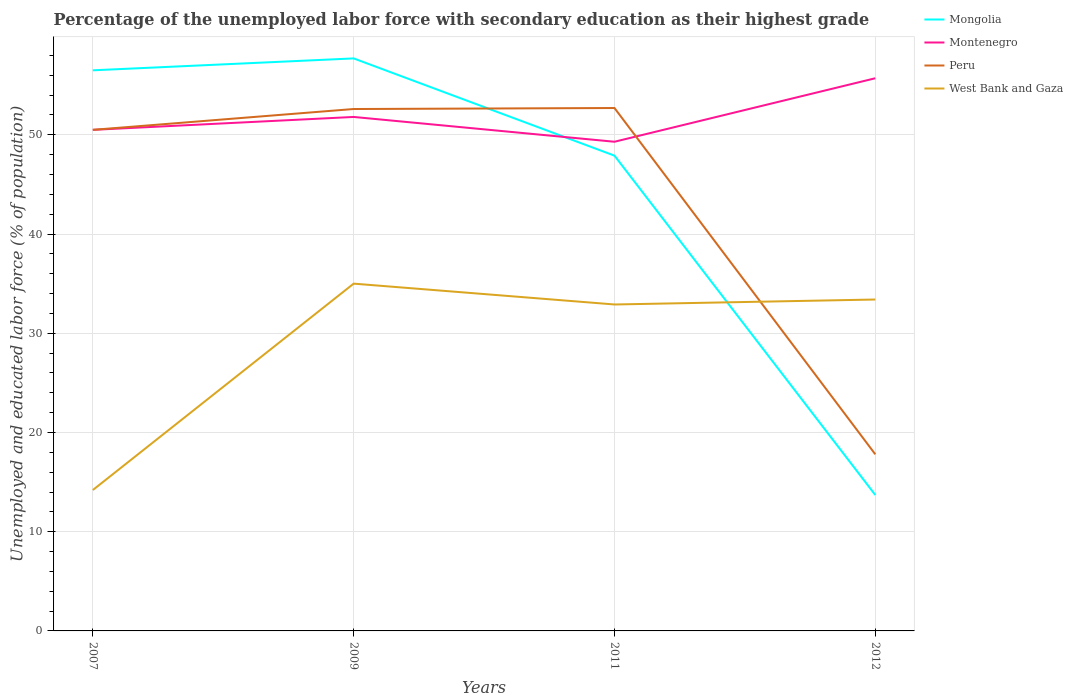Does the line corresponding to West Bank and Gaza intersect with the line corresponding to Montenegro?
Your answer should be very brief. No. Is the number of lines equal to the number of legend labels?
Offer a very short reply. Yes. Across all years, what is the maximum percentage of the unemployed labor force with secondary education in Peru?
Offer a very short reply. 17.8. What is the total percentage of the unemployed labor force with secondary education in West Bank and Gaza in the graph?
Offer a very short reply. -19.2. What is the difference between the highest and the second highest percentage of the unemployed labor force with secondary education in Montenegro?
Provide a succinct answer. 6.4. What is the difference between the highest and the lowest percentage of the unemployed labor force with secondary education in Peru?
Keep it short and to the point. 3. How many years are there in the graph?
Provide a short and direct response. 4. Are the values on the major ticks of Y-axis written in scientific E-notation?
Provide a succinct answer. No. Does the graph contain any zero values?
Your answer should be compact. No. Does the graph contain grids?
Your answer should be very brief. Yes. Where does the legend appear in the graph?
Your response must be concise. Top right. What is the title of the graph?
Ensure brevity in your answer.  Percentage of the unemployed labor force with secondary education as their highest grade. Does "Austria" appear as one of the legend labels in the graph?
Your answer should be compact. No. What is the label or title of the Y-axis?
Your answer should be compact. Unemployed and educated labor force (% of population). What is the Unemployed and educated labor force (% of population) of Mongolia in 2007?
Your answer should be very brief. 56.5. What is the Unemployed and educated labor force (% of population) of Montenegro in 2007?
Give a very brief answer. 50.5. What is the Unemployed and educated labor force (% of population) in Peru in 2007?
Your answer should be very brief. 50.5. What is the Unemployed and educated labor force (% of population) in West Bank and Gaza in 2007?
Give a very brief answer. 14.2. What is the Unemployed and educated labor force (% of population) of Mongolia in 2009?
Ensure brevity in your answer.  57.7. What is the Unemployed and educated labor force (% of population) in Montenegro in 2009?
Offer a very short reply. 51.8. What is the Unemployed and educated labor force (% of population) of Peru in 2009?
Give a very brief answer. 52.6. What is the Unemployed and educated labor force (% of population) of West Bank and Gaza in 2009?
Your answer should be compact. 35. What is the Unemployed and educated labor force (% of population) in Mongolia in 2011?
Provide a short and direct response. 47.9. What is the Unemployed and educated labor force (% of population) in Montenegro in 2011?
Provide a succinct answer. 49.3. What is the Unemployed and educated labor force (% of population) in Peru in 2011?
Give a very brief answer. 52.7. What is the Unemployed and educated labor force (% of population) in West Bank and Gaza in 2011?
Offer a terse response. 32.9. What is the Unemployed and educated labor force (% of population) of Mongolia in 2012?
Make the answer very short. 13.7. What is the Unemployed and educated labor force (% of population) of Montenegro in 2012?
Provide a succinct answer. 55.7. What is the Unemployed and educated labor force (% of population) in Peru in 2012?
Keep it short and to the point. 17.8. What is the Unemployed and educated labor force (% of population) in West Bank and Gaza in 2012?
Your answer should be very brief. 33.4. Across all years, what is the maximum Unemployed and educated labor force (% of population) in Mongolia?
Ensure brevity in your answer.  57.7. Across all years, what is the maximum Unemployed and educated labor force (% of population) in Montenegro?
Your answer should be very brief. 55.7. Across all years, what is the maximum Unemployed and educated labor force (% of population) in Peru?
Give a very brief answer. 52.7. Across all years, what is the minimum Unemployed and educated labor force (% of population) in Mongolia?
Keep it short and to the point. 13.7. Across all years, what is the minimum Unemployed and educated labor force (% of population) of Montenegro?
Provide a short and direct response. 49.3. Across all years, what is the minimum Unemployed and educated labor force (% of population) of Peru?
Your response must be concise. 17.8. Across all years, what is the minimum Unemployed and educated labor force (% of population) in West Bank and Gaza?
Offer a very short reply. 14.2. What is the total Unemployed and educated labor force (% of population) in Mongolia in the graph?
Give a very brief answer. 175.8. What is the total Unemployed and educated labor force (% of population) of Montenegro in the graph?
Offer a very short reply. 207.3. What is the total Unemployed and educated labor force (% of population) in Peru in the graph?
Offer a terse response. 173.6. What is the total Unemployed and educated labor force (% of population) in West Bank and Gaza in the graph?
Your response must be concise. 115.5. What is the difference between the Unemployed and educated labor force (% of population) of West Bank and Gaza in 2007 and that in 2009?
Keep it short and to the point. -20.8. What is the difference between the Unemployed and educated labor force (% of population) of Mongolia in 2007 and that in 2011?
Offer a very short reply. 8.6. What is the difference between the Unemployed and educated labor force (% of population) of Peru in 2007 and that in 2011?
Ensure brevity in your answer.  -2.2. What is the difference between the Unemployed and educated labor force (% of population) in West Bank and Gaza in 2007 and that in 2011?
Your answer should be compact. -18.7. What is the difference between the Unemployed and educated labor force (% of population) of Mongolia in 2007 and that in 2012?
Make the answer very short. 42.8. What is the difference between the Unemployed and educated labor force (% of population) in Peru in 2007 and that in 2012?
Give a very brief answer. 32.7. What is the difference between the Unemployed and educated labor force (% of population) in West Bank and Gaza in 2007 and that in 2012?
Provide a succinct answer. -19.2. What is the difference between the Unemployed and educated labor force (% of population) in Mongolia in 2009 and that in 2011?
Your answer should be very brief. 9.8. What is the difference between the Unemployed and educated labor force (% of population) in Montenegro in 2009 and that in 2012?
Ensure brevity in your answer.  -3.9. What is the difference between the Unemployed and educated labor force (% of population) in Peru in 2009 and that in 2012?
Make the answer very short. 34.8. What is the difference between the Unemployed and educated labor force (% of population) in West Bank and Gaza in 2009 and that in 2012?
Your response must be concise. 1.6. What is the difference between the Unemployed and educated labor force (% of population) of Mongolia in 2011 and that in 2012?
Your answer should be very brief. 34.2. What is the difference between the Unemployed and educated labor force (% of population) of Montenegro in 2011 and that in 2012?
Offer a terse response. -6.4. What is the difference between the Unemployed and educated labor force (% of population) of Peru in 2011 and that in 2012?
Your answer should be very brief. 34.9. What is the difference between the Unemployed and educated labor force (% of population) of Mongolia in 2007 and the Unemployed and educated labor force (% of population) of West Bank and Gaza in 2009?
Give a very brief answer. 21.5. What is the difference between the Unemployed and educated labor force (% of population) of Montenegro in 2007 and the Unemployed and educated labor force (% of population) of Peru in 2009?
Your response must be concise. -2.1. What is the difference between the Unemployed and educated labor force (% of population) in Montenegro in 2007 and the Unemployed and educated labor force (% of population) in West Bank and Gaza in 2009?
Offer a very short reply. 15.5. What is the difference between the Unemployed and educated labor force (% of population) of Mongolia in 2007 and the Unemployed and educated labor force (% of population) of Montenegro in 2011?
Make the answer very short. 7.2. What is the difference between the Unemployed and educated labor force (% of population) in Mongolia in 2007 and the Unemployed and educated labor force (% of population) in West Bank and Gaza in 2011?
Your answer should be compact. 23.6. What is the difference between the Unemployed and educated labor force (% of population) in Montenegro in 2007 and the Unemployed and educated labor force (% of population) in Peru in 2011?
Your response must be concise. -2.2. What is the difference between the Unemployed and educated labor force (% of population) in Montenegro in 2007 and the Unemployed and educated labor force (% of population) in West Bank and Gaza in 2011?
Make the answer very short. 17.6. What is the difference between the Unemployed and educated labor force (% of population) of Mongolia in 2007 and the Unemployed and educated labor force (% of population) of Montenegro in 2012?
Ensure brevity in your answer.  0.8. What is the difference between the Unemployed and educated labor force (% of population) of Mongolia in 2007 and the Unemployed and educated labor force (% of population) of Peru in 2012?
Ensure brevity in your answer.  38.7. What is the difference between the Unemployed and educated labor force (% of population) of Mongolia in 2007 and the Unemployed and educated labor force (% of population) of West Bank and Gaza in 2012?
Provide a short and direct response. 23.1. What is the difference between the Unemployed and educated labor force (% of population) in Montenegro in 2007 and the Unemployed and educated labor force (% of population) in Peru in 2012?
Provide a succinct answer. 32.7. What is the difference between the Unemployed and educated labor force (% of population) of Mongolia in 2009 and the Unemployed and educated labor force (% of population) of West Bank and Gaza in 2011?
Ensure brevity in your answer.  24.8. What is the difference between the Unemployed and educated labor force (% of population) in Mongolia in 2009 and the Unemployed and educated labor force (% of population) in Montenegro in 2012?
Your answer should be very brief. 2. What is the difference between the Unemployed and educated labor force (% of population) of Mongolia in 2009 and the Unemployed and educated labor force (% of population) of Peru in 2012?
Offer a terse response. 39.9. What is the difference between the Unemployed and educated labor force (% of population) of Mongolia in 2009 and the Unemployed and educated labor force (% of population) of West Bank and Gaza in 2012?
Your response must be concise. 24.3. What is the difference between the Unemployed and educated labor force (% of population) in Montenegro in 2009 and the Unemployed and educated labor force (% of population) in Peru in 2012?
Offer a terse response. 34. What is the difference between the Unemployed and educated labor force (% of population) of Montenegro in 2009 and the Unemployed and educated labor force (% of population) of West Bank and Gaza in 2012?
Keep it short and to the point. 18.4. What is the difference between the Unemployed and educated labor force (% of population) of Mongolia in 2011 and the Unemployed and educated labor force (% of population) of Montenegro in 2012?
Keep it short and to the point. -7.8. What is the difference between the Unemployed and educated labor force (% of population) of Mongolia in 2011 and the Unemployed and educated labor force (% of population) of Peru in 2012?
Ensure brevity in your answer.  30.1. What is the difference between the Unemployed and educated labor force (% of population) in Montenegro in 2011 and the Unemployed and educated labor force (% of population) in Peru in 2012?
Give a very brief answer. 31.5. What is the difference between the Unemployed and educated labor force (% of population) in Peru in 2011 and the Unemployed and educated labor force (% of population) in West Bank and Gaza in 2012?
Offer a very short reply. 19.3. What is the average Unemployed and educated labor force (% of population) in Mongolia per year?
Your answer should be very brief. 43.95. What is the average Unemployed and educated labor force (% of population) in Montenegro per year?
Ensure brevity in your answer.  51.83. What is the average Unemployed and educated labor force (% of population) of Peru per year?
Provide a succinct answer. 43.4. What is the average Unemployed and educated labor force (% of population) in West Bank and Gaza per year?
Your response must be concise. 28.88. In the year 2007, what is the difference between the Unemployed and educated labor force (% of population) in Mongolia and Unemployed and educated labor force (% of population) in West Bank and Gaza?
Your response must be concise. 42.3. In the year 2007, what is the difference between the Unemployed and educated labor force (% of population) in Montenegro and Unemployed and educated labor force (% of population) in Peru?
Your response must be concise. 0. In the year 2007, what is the difference between the Unemployed and educated labor force (% of population) of Montenegro and Unemployed and educated labor force (% of population) of West Bank and Gaza?
Give a very brief answer. 36.3. In the year 2007, what is the difference between the Unemployed and educated labor force (% of population) in Peru and Unemployed and educated labor force (% of population) in West Bank and Gaza?
Your answer should be very brief. 36.3. In the year 2009, what is the difference between the Unemployed and educated labor force (% of population) in Mongolia and Unemployed and educated labor force (% of population) in West Bank and Gaza?
Offer a very short reply. 22.7. In the year 2011, what is the difference between the Unemployed and educated labor force (% of population) in Mongolia and Unemployed and educated labor force (% of population) in Montenegro?
Your response must be concise. -1.4. In the year 2011, what is the difference between the Unemployed and educated labor force (% of population) of Mongolia and Unemployed and educated labor force (% of population) of West Bank and Gaza?
Offer a terse response. 15. In the year 2011, what is the difference between the Unemployed and educated labor force (% of population) of Montenegro and Unemployed and educated labor force (% of population) of Peru?
Ensure brevity in your answer.  -3.4. In the year 2011, what is the difference between the Unemployed and educated labor force (% of population) in Peru and Unemployed and educated labor force (% of population) in West Bank and Gaza?
Your response must be concise. 19.8. In the year 2012, what is the difference between the Unemployed and educated labor force (% of population) of Mongolia and Unemployed and educated labor force (% of population) of Montenegro?
Offer a terse response. -42. In the year 2012, what is the difference between the Unemployed and educated labor force (% of population) of Mongolia and Unemployed and educated labor force (% of population) of Peru?
Your answer should be very brief. -4.1. In the year 2012, what is the difference between the Unemployed and educated labor force (% of population) in Mongolia and Unemployed and educated labor force (% of population) in West Bank and Gaza?
Keep it short and to the point. -19.7. In the year 2012, what is the difference between the Unemployed and educated labor force (% of population) of Montenegro and Unemployed and educated labor force (% of population) of Peru?
Provide a succinct answer. 37.9. In the year 2012, what is the difference between the Unemployed and educated labor force (% of population) of Montenegro and Unemployed and educated labor force (% of population) of West Bank and Gaza?
Your answer should be compact. 22.3. In the year 2012, what is the difference between the Unemployed and educated labor force (% of population) of Peru and Unemployed and educated labor force (% of population) of West Bank and Gaza?
Your answer should be compact. -15.6. What is the ratio of the Unemployed and educated labor force (% of population) of Mongolia in 2007 to that in 2009?
Ensure brevity in your answer.  0.98. What is the ratio of the Unemployed and educated labor force (% of population) of Montenegro in 2007 to that in 2009?
Your response must be concise. 0.97. What is the ratio of the Unemployed and educated labor force (% of population) of Peru in 2007 to that in 2009?
Your answer should be compact. 0.96. What is the ratio of the Unemployed and educated labor force (% of population) of West Bank and Gaza in 2007 to that in 2009?
Make the answer very short. 0.41. What is the ratio of the Unemployed and educated labor force (% of population) of Mongolia in 2007 to that in 2011?
Keep it short and to the point. 1.18. What is the ratio of the Unemployed and educated labor force (% of population) of Montenegro in 2007 to that in 2011?
Give a very brief answer. 1.02. What is the ratio of the Unemployed and educated labor force (% of population) in West Bank and Gaza in 2007 to that in 2011?
Provide a succinct answer. 0.43. What is the ratio of the Unemployed and educated labor force (% of population) in Mongolia in 2007 to that in 2012?
Make the answer very short. 4.12. What is the ratio of the Unemployed and educated labor force (% of population) in Montenegro in 2007 to that in 2012?
Provide a succinct answer. 0.91. What is the ratio of the Unemployed and educated labor force (% of population) of Peru in 2007 to that in 2012?
Offer a very short reply. 2.84. What is the ratio of the Unemployed and educated labor force (% of population) of West Bank and Gaza in 2007 to that in 2012?
Your answer should be compact. 0.43. What is the ratio of the Unemployed and educated labor force (% of population) in Mongolia in 2009 to that in 2011?
Your response must be concise. 1.2. What is the ratio of the Unemployed and educated labor force (% of population) in Montenegro in 2009 to that in 2011?
Offer a very short reply. 1.05. What is the ratio of the Unemployed and educated labor force (% of population) in Peru in 2009 to that in 2011?
Your answer should be very brief. 1. What is the ratio of the Unemployed and educated labor force (% of population) of West Bank and Gaza in 2009 to that in 2011?
Your answer should be compact. 1.06. What is the ratio of the Unemployed and educated labor force (% of population) of Mongolia in 2009 to that in 2012?
Your response must be concise. 4.21. What is the ratio of the Unemployed and educated labor force (% of population) of Peru in 2009 to that in 2012?
Offer a terse response. 2.96. What is the ratio of the Unemployed and educated labor force (% of population) in West Bank and Gaza in 2009 to that in 2012?
Provide a short and direct response. 1.05. What is the ratio of the Unemployed and educated labor force (% of population) in Mongolia in 2011 to that in 2012?
Give a very brief answer. 3.5. What is the ratio of the Unemployed and educated labor force (% of population) of Montenegro in 2011 to that in 2012?
Give a very brief answer. 0.89. What is the ratio of the Unemployed and educated labor force (% of population) of Peru in 2011 to that in 2012?
Your answer should be compact. 2.96. What is the ratio of the Unemployed and educated labor force (% of population) of West Bank and Gaza in 2011 to that in 2012?
Offer a terse response. 0.98. What is the difference between the highest and the lowest Unemployed and educated labor force (% of population) in Mongolia?
Your answer should be very brief. 44. What is the difference between the highest and the lowest Unemployed and educated labor force (% of population) in Montenegro?
Offer a terse response. 6.4. What is the difference between the highest and the lowest Unemployed and educated labor force (% of population) of Peru?
Give a very brief answer. 34.9. What is the difference between the highest and the lowest Unemployed and educated labor force (% of population) in West Bank and Gaza?
Make the answer very short. 20.8. 